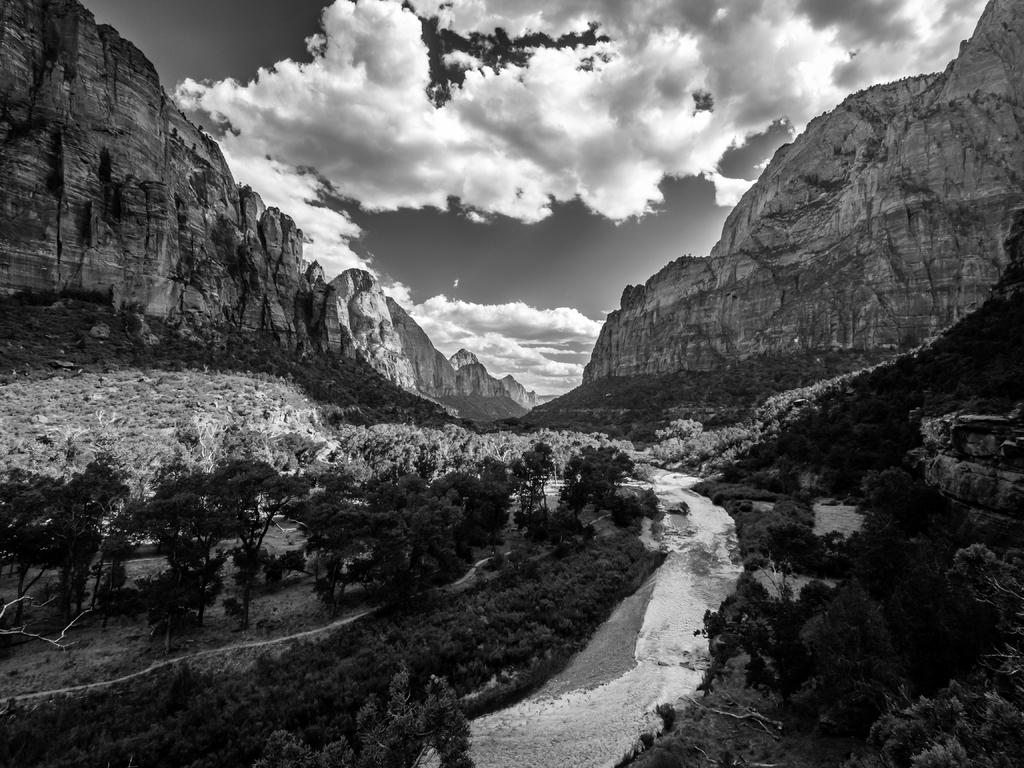What is the color scheme of the image? The image is black and white. What can be seen in the middle of the image? Water is flowing on the ground in the middle of the image. What type of natural environment is visible in the background of the image? There are trees, mountains, and clouds in the background of the image. Can you tell me where the toad is sitting in the image? There is no toad present in the image. What type of meat is being cooked in the image? There is no meat or cooking activity depicted in the image. 